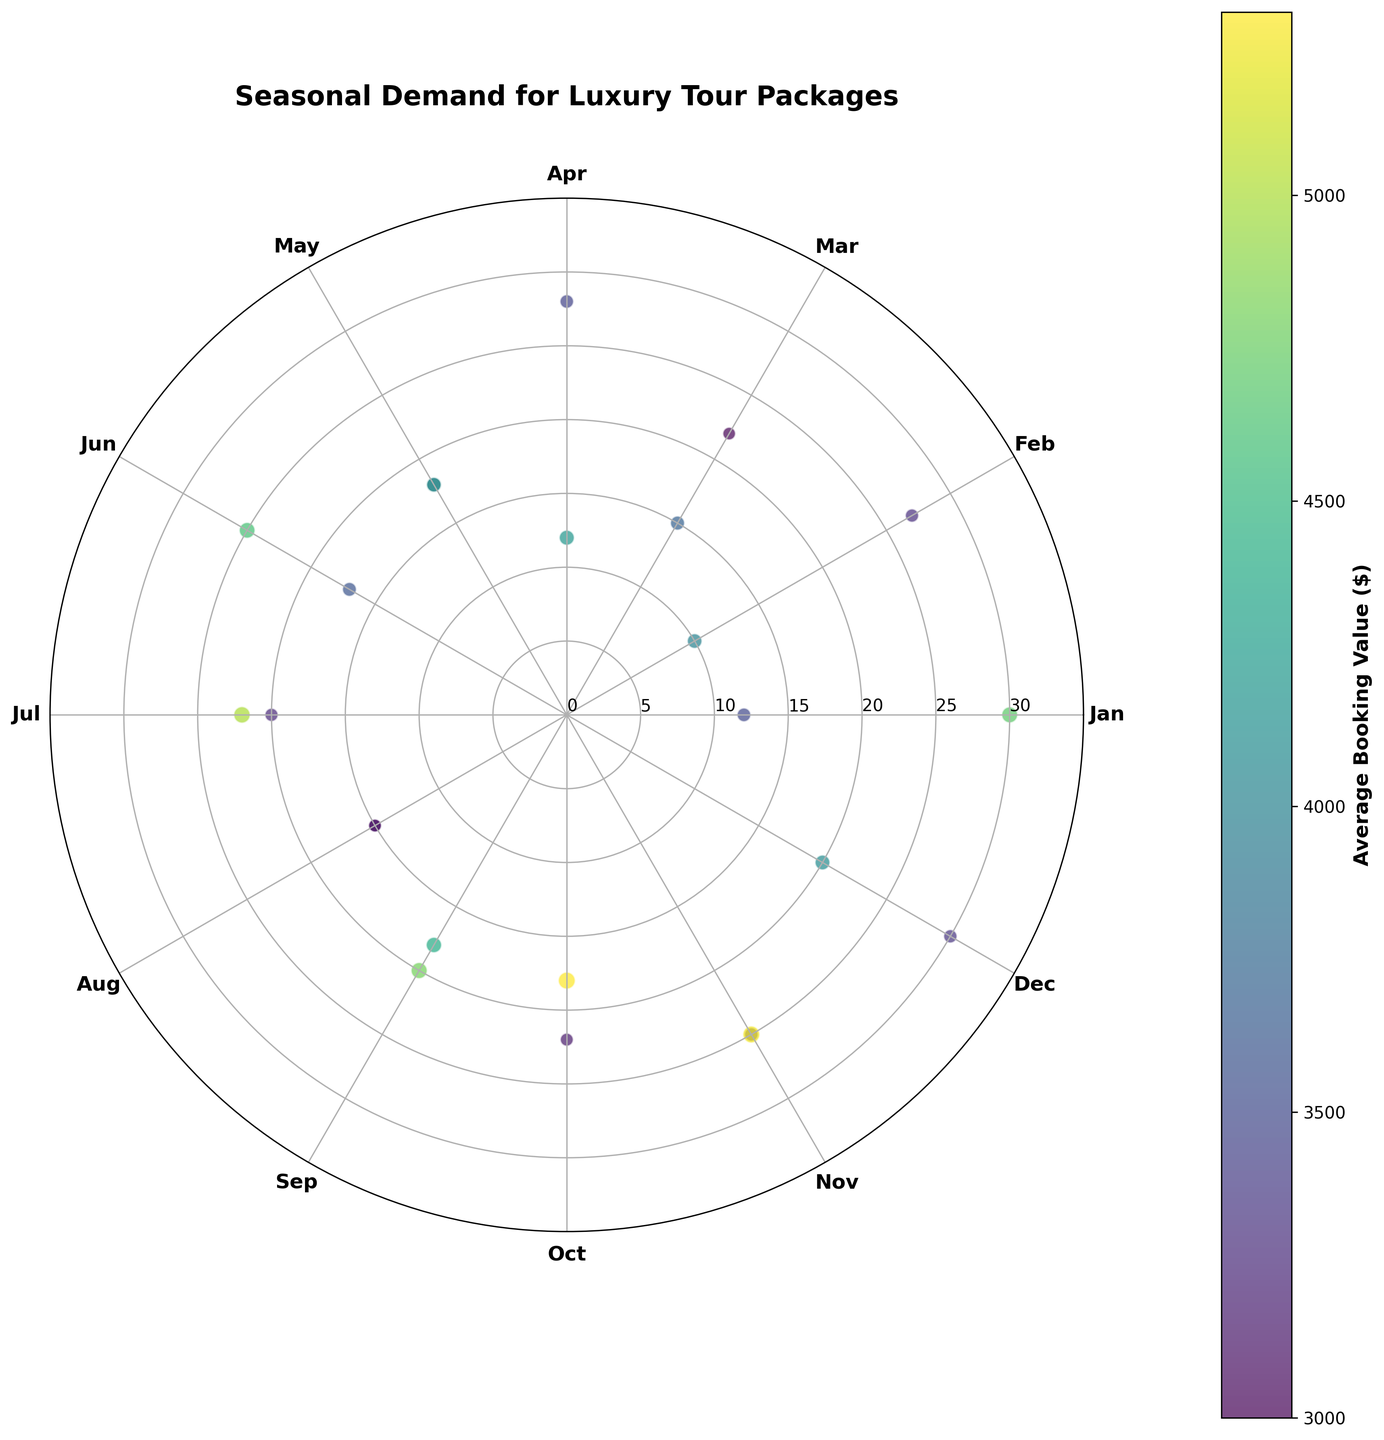Which month has the highest number of bookings for White Sands Beach? By looking at the plot, find the data points that represent bookings for White Sands Beach and identify which month has the highest number of bookings.
Answer: December What is the average booking value in October for Rainforest Trek? Locate the data point for Rainforest Trek in October and read the color-coded average booking value from the plot's color bar.
Answer: 3080 Which location has the highest average booking value in May? Identify the data points for May and find the one with the highest average booking value by looking at the color intensity and referring to the color bar.
Answer: Ocean View Resort How many total bookings were made in July across all locations? Sum the number of bookings from all data points representing bookings in July.
Answer: 57 Compare the number of bookings in February between White Sands Beach and Ocean View Resort. Which location had more? Find the data points for both locations in February and compare the values.
Answer: White Sands Beach What is the range of average booking values displayed on the plot? Refer to the color bar to find the minimum and maximum average booking values represented.
Answer: 3000 to 5300 During which month is the demand for Coral Reef Adventure Park the highest? Identify the data points for Coral Reef Adventure Park and determine which one has the highest number of bookings by referring to the radial axis.
Answer: July What is the difference in the number of bookings between January and March for White Sands Beach? Subtract the number of bookings in January from those in March for White Sands Beach.
Answer: 5 Which month shows the highest average booking value for Ocean View Resort? Identify the data points for Ocean View Resort and determine the highest average booking value using the color bar.
Answer: May Is there a month where both Rainforest Trek and Ocean View Resort have bookings, and if so, what is that month? Check the plot for any month where data points exist for both Rainforest Trek and Ocean View Resort.
Answer: April 